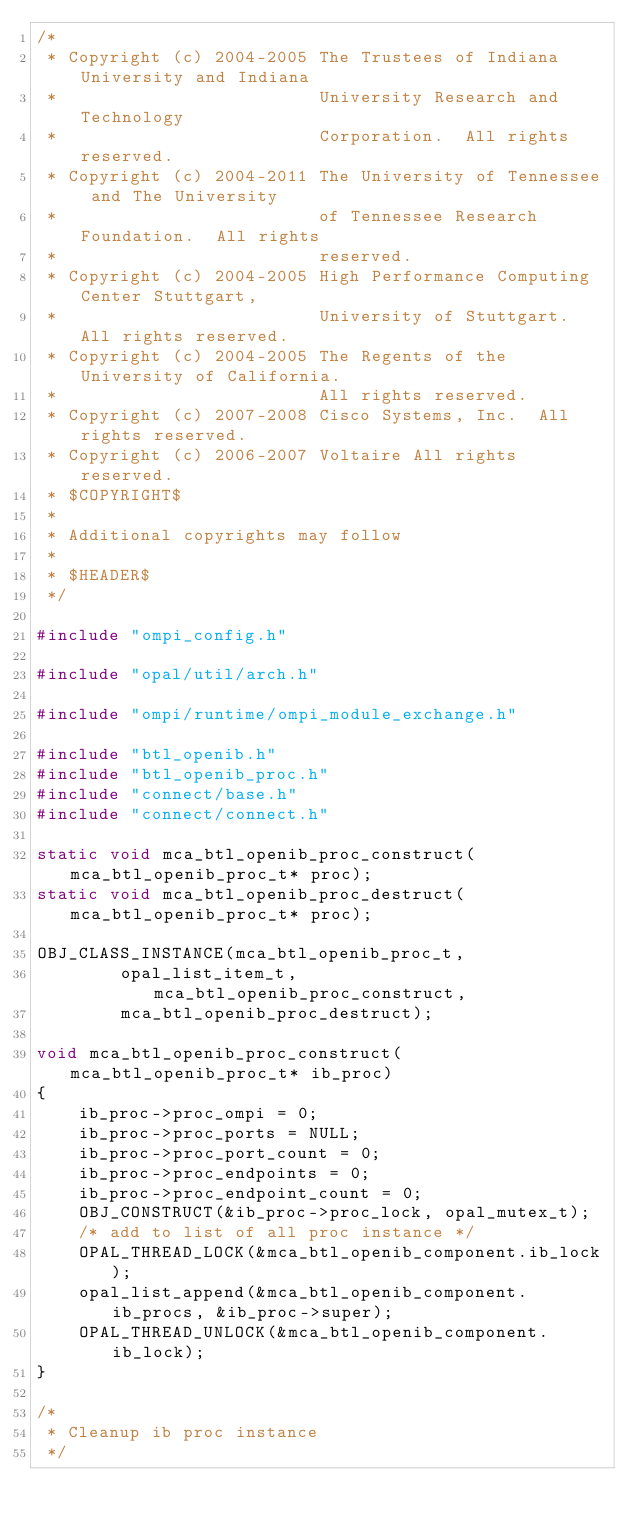Convert code to text. <code><loc_0><loc_0><loc_500><loc_500><_C_>/*
 * Copyright (c) 2004-2005 The Trustees of Indiana University and Indiana
 *                         University Research and Technology
 *                         Corporation.  All rights reserved.
 * Copyright (c) 2004-2011 The University of Tennessee and The University
 *                         of Tennessee Research Foundation.  All rights
 *                         reserved.
 * Copyright (c) 2004-2005 High Performance Computing Center Stuttgart,
 *                         University of Stuttgart.  All rights reserved.
 * Copyright (c) 2004-2005 The Regents of the University of California.
 *                         All rights reserved.
 * Copyright (c) 2007-2008 Cisco Systems, Inc.  All rights reserved.
 * Copyright (c) 2006-2007 Voltaire All rights reserved.
 * $COPYRIGHT$
 *
 * Additional copyrights may follow
 *
 * $HEADER$
 */

#include "ompi_config.h"

#include "opal/util/arch.h"

#include "ompi/runtime/ompi_module_exchange.h"

#include "btl_openib.h"
#include "btl_openib_proc.h"
#include "connect/base.h"
#include "connect/connect.h"

static void mca_btl_openib_proc_construct(mca_btl_openib_proc_t* proc);
static void mca_btl_openib_proc_destruct(mca_btl_openib_proc_t* proc);

OBJ_CLASS_INSTANCE(mca_btl_openib_proc_t,
        opal_list_item_t, mca_btl_openib_proc_construct,
        mca_btl_openib_proc_destruct);

void mca_btl_openib_proc_construct(mca_btl_openib_proc_t* ib_proc)
{
    ib_proc->proc_ompi = 0;
    ib_proc->proc_ports = NULL;
    ib_proc->proc_port_count = 0;
    ib_proc->proc_endpoints = 0;
    ib_proc->proc_endpoint_count = 0;
    OBJ_CONSTRUCT(&ib_proc->proc_lock, opal_mutex_t);
    /* add to list of all proc instance */
    OPAL_THREAD_LOCK(&mca_btl_openib_component.ib_lock);
    opal_list_append(&mca_btl_openib_component.ib_procs, &ib_proc->super);
    OPAL_THREAD_UNLOCK(&mca_btl_openib_component.ib_lock);
}

/*
 * Cleanup ib proc instance
 */
</code> 